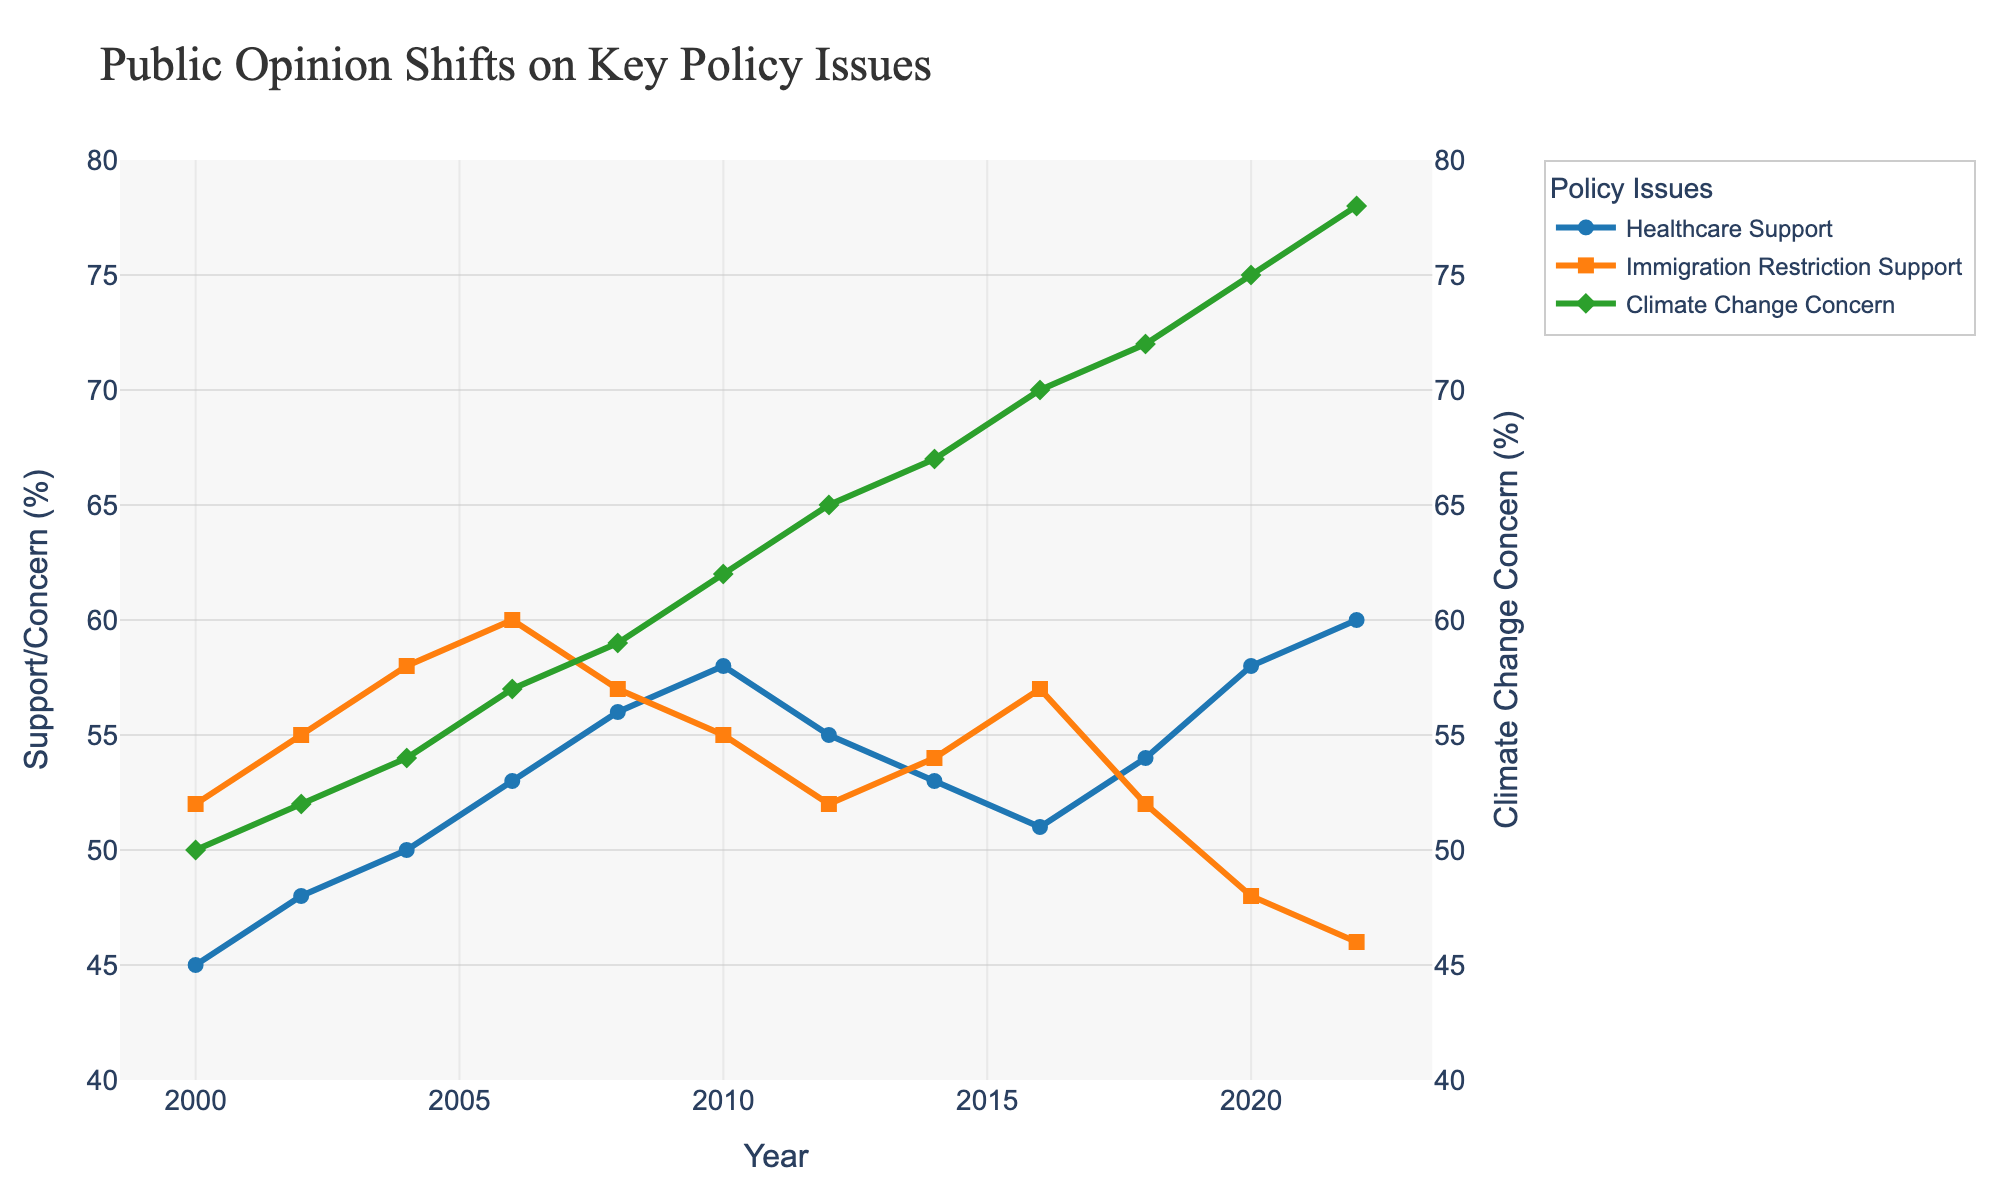What's the percentage increase in Climate Change Concern from 2000 to 2022? To calculate the percentage increase, subtract the initial value (2000) from the final value (2022), then divide by the initial value and multiply by 100. Climate Change Concern in 2000 was 50%, and in 2022 it was 78%. The calculation is ((78-50)/50)*100.
Answer: 56% In which year did Healthcare Support first exceed 50%? Look for the first year where the Healthcare Support percentage goes above 50% on the chart. The data shows Healthcare Support exceeds 50% in the year 2004.
Answer: 2004 Compare the trends of Immigration Restriction Support and Climate Change Concern between 2012 and 2016. Which diverges more? Analyze the changes in both metrics between 2012 and 2016. Immigration Restriction Support goes from 52% to 57%, while Climate Change Concern rises from 65% to 70%. Climate Change Concern increases by 5% (70-65), whereas Immigration Restriction Support increases by 5% (57-52). Since both metrics change by the same percentage, neither diverges more.
Answer: Neither Which issue had the most fluctuating trend, and how can you tell? Examine the visual smoothness of the lines representing each issue over the years. Healthcare Support and Climate Change Concern show smoother trends, while Immigration Restriction Support fluctuates more. This is evident as the line for Immigration Restriction Support exhibits more peaks and troughs over time.
Answer: Immigration Restriction Support What is the average level of Climate Change Concern across the entire shown period? To find the average, add the percentages for each year and then divide by the total number of years (13). Sum: 50+52+54+57+59+62+65+67+70+72+75+78 = 761. Average is 761/13.
Answer: 58.54% What is the difference in Healthcare Support between 2010 and 2014? Look at the values for Healthcare Support in 2010 and 2014, which are 58% and 53% respectively. Subtract the 2014 value from the 2010 value. The difference is 58% - 53%.
Answer: 5% Which year saw the sharpest decline in Immigration Restriction Support? Locate the points on the graph where the Immigration Restriction Support line drops steeply. The greatest decline is between 2018 (52%) and 2020 (48%). Calculate the change: 52% - 48%.
Answer: 2018-2020 Is there a year where both Healthcare Support and Climate Change Concern increased but Immigration Restriction Support decreased? Review the individual trend lines year by year. The dataset reveals that in 2020, Healthcare Support increased (from 54% in 2018 to 58%), Climate Change Concern also increased (from 72% in 2018 to 75%), and Immigration Restriction Support decreased (from 52% in 2018 to 48%).
Answer: 2020 